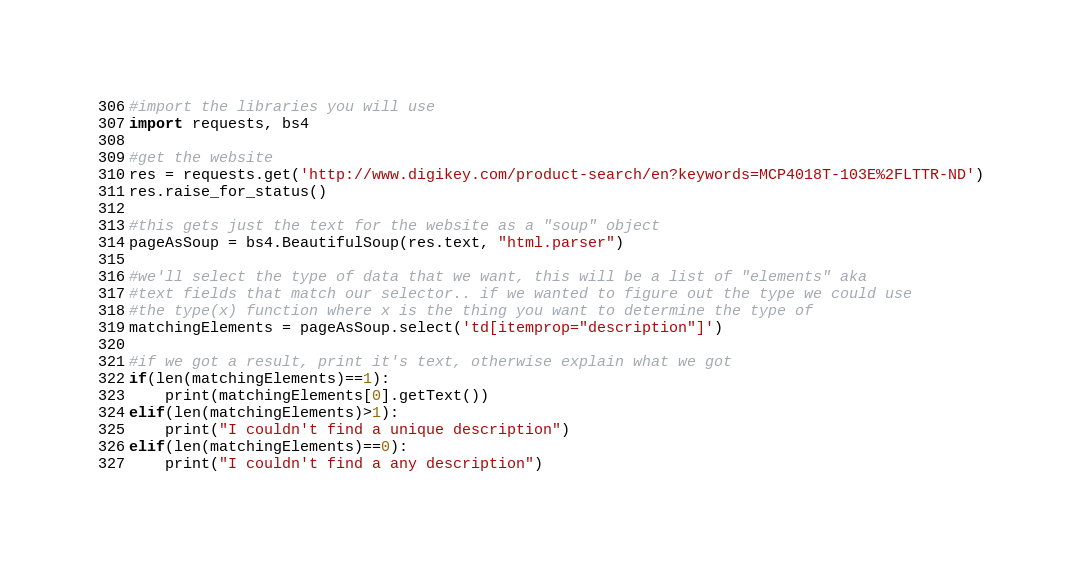<code> <loc_0><loc_0><loc_500><loc_500><_Python_>#import the libraries you will use
import requests, bs4

#get the website
res = requests.get('http://www.digikey.com/product-search/en?keywords=MCP4018T-103E%2FLTTR-ND')
res.raise_for_status()

#this gets just the text for the website as a "soup" object
pageAsSoup = bs4.BeautifulSoup(res.text, "html.parser")

#we'll select the type of data that we want, this will be a list of "elements" aka
#text fields that match our selector.. if we wanted to figure out the type we could use
#the type(x) function where x is the thing you want to determine the type of
matchingElements = pageAsSoup.select('td[itemprop="description"]')

#if we got a result, print it's text, otherwise explain what we got
if(len(matchingElements)==1):
    print(matchingElements[0].getText())
elif(len(matchingElements)>1):
    print("I couldn't find a unique description")
elif(len(matchingElements)==0):
    print("I couldn't find a any description")
</code> 